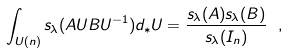<formula> <loc_0><loc_0><loc_500><loc_500>\int _ { U ( n ) } s _ { \lambda } ( A U B U ^ { - 1 } ) d _ { * } U = \frac { s _ { \lambda } ( A ) s _ { \lambda } ( B ) } { s _ { \lambda } ( I _ { n } ) } \ ,</formula> 